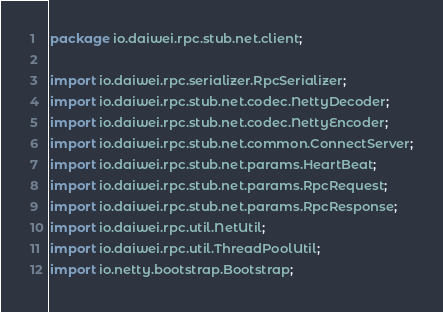Convert code to text. <code><loc_0><loc_0><loc_500><loc_500><_Java_>package io.daiwei.rpc.stub.net.client;

import io.daiwei.rpc.serializer.RpcSerializer;
import io.daiwei.rpc.stub.net.codec.NettyDecoder;
import io.daiwei.rpc.stub.net.codec.NettyEncoder;
import io.daiwei.rpc.stub.net.common.ConnectServer;
import io.daiwei.rpc.stub.net.params.HeartBeat;
import io.daiwei.rpc.stub.net.params.RpcRequest;
import io.daiwei.rpc.stub.net.params.RpcResponse;
import io.daiwei.rpc.util.NetUtil;
import io.daiwei.rpc.util.ThreadPoolUtil;
import io.netty.bootstrap.Bootstrap;</code> 